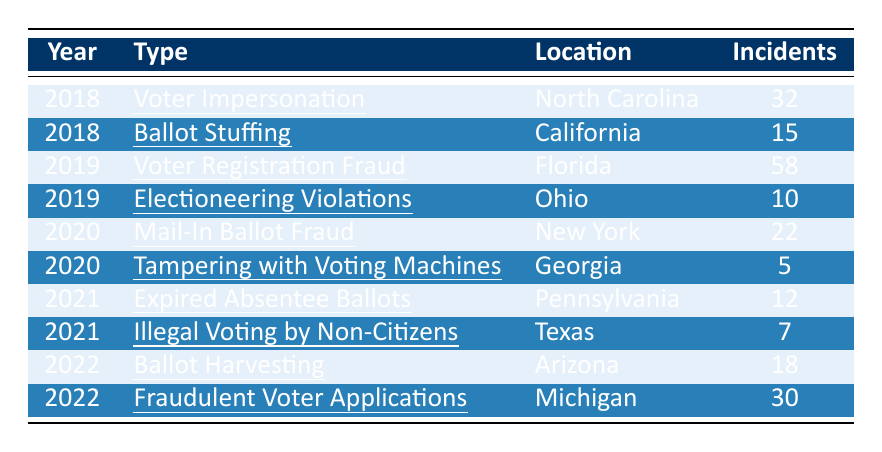What type of election fraud incident had the highest reported number of incidents in 2019? The table shows that in 2019, the incident with the highest number of reports was "Voter Registration Fraud" with 58 incidents.
Answer: Voter Registration Fraud How many incidents of Mail-In Ballot Fraud were reported in 2020? According to the table, there were 22 incidents of "Mail-In Ballot Fraud" reported in 2020.
Answer: 22 What is the total number of reported election fraud incidents from 2018 to 2022? By summing the incidents from each year: 32 (2018) + 15 (2018) + 58 (2019) + 10 (2019) + 22 (2020) + 5 (2020) + 12 (2021) + 7 (2021) + 18 (2022) + 30 (2022) =  222 total incidents.
Answer: 222 Did any incidents of "Tampering with Voting Machines" occur in 2019? The table does not list any incidents of "Tampering with Voting Machines" in 2019, as it appears only in 2020 with 5 incidents.
Answer: No Which type of election fraud incident was reported in both 2019 and 2020? The table shows no type of election fraud incident was reported in both 2019 and 2020, as each year has unique incidents listed.
Answer: None What is the average number of incidents reported for the year 2022? For 2022, there are 2 incidents: "Ballot Harvesting" (18 incidents) and "Fraudulent Voter Applications" (30 incidents). Adding them gives 48 incidents, and dividing by 2 yields an average of 24.
Answer: 24 Which state had the lowest number of incidents reported in the table? The incidents were 5 (Georgia), 7 (Texas), 10 (Ohio), 12 (Pennsylvania), 15 (California), 18 (Arizona), 22 (New York), 30 (Michigan), 32 (North Carolina), and 58 (Florida). Georgia had the lowest reported incident count of 5.
Answer: Georgia How many incidents were reported in Arizona compared to California? The table indicates that Arizona had 18 incidents, while California had 15 incidents. Comparing the two, Arizona had 3 more incidents than California.
Answer: Arizona had 3 more incidents What were the total incidents reported in 2021? In 2021, there are 2 incidents listed: "Expired Absentee Ballots" (12 incidents) and "Illegal Voting by Non-Citizens" (7 incidents). Adding these gives a total of 19 incidents for 2021.
Answer: 19 